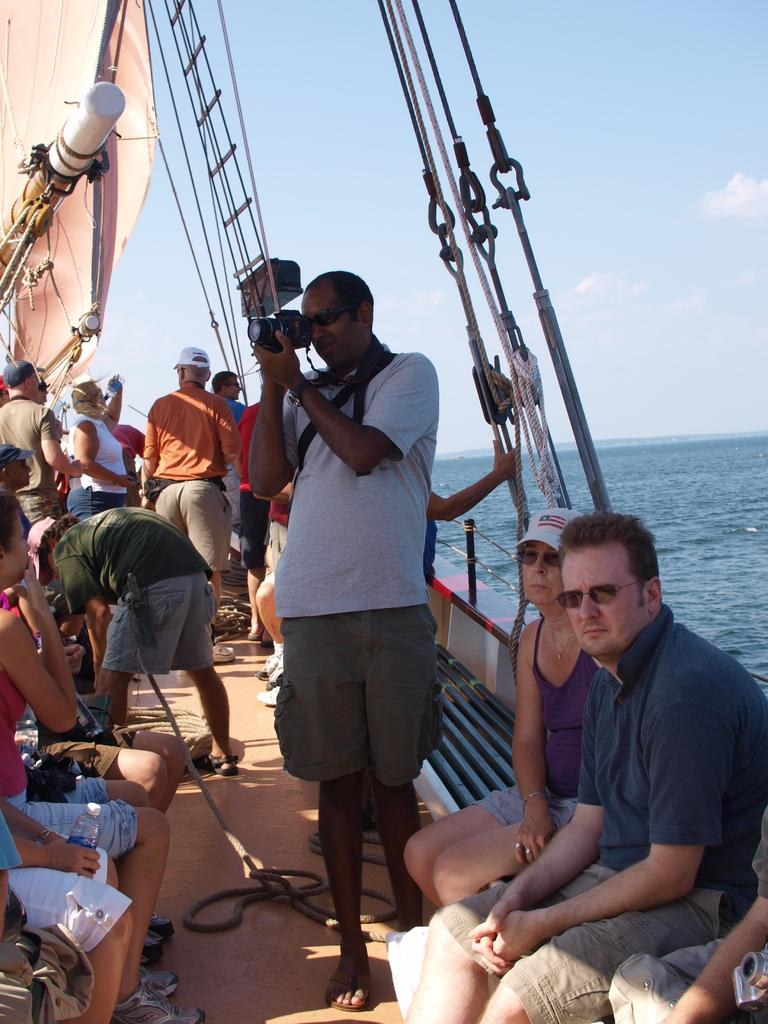Who is present in the image? There are people in the image. What are the people doing in the image? The people are traveling on a ship. Where is the ship located in the image? The ship is on a river. What might the person holding a camera be doing? The person holding a camera might be taking pictures or recording the scene. What can be seen in the background of the image? There is a sky visible in the background of the image. How does the person with the wound react to the dust in the image? There is no person with a wound or dust present in the image. 